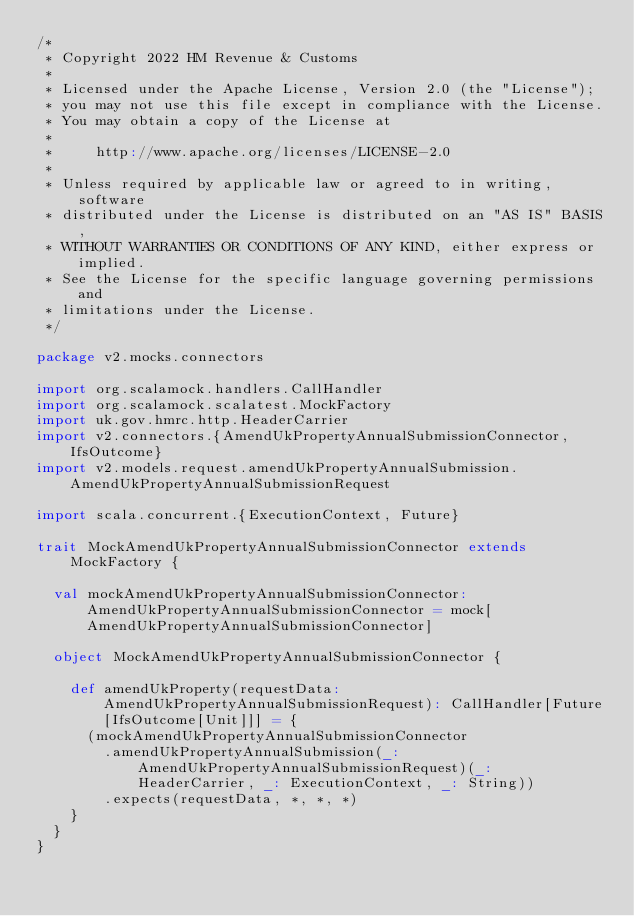Convert code to text. <code><loc_0><loc_0><loc_500><loc_500><_Scala_>/*
 * Copyright 2022 HM Revenue & Customs
 *
 * Licensed under the Apache License, Version 2.0 (the "License");
 * you may not use this file except in compliance with the License.
 * You may obtain a copy of the License at
 *
 *     http://www.apache.org/licenses/LICENSE-2.0
 *
 * Unless required by applicable law or agreed to in writing, software
 * distributed under the License is distributed on an "AS IS" BASIS,
 * WITHOUT WARRANTIES OR CONDITIONS OF ANY KIND, either express or implied.
 * See the License for the specific language governing permissions and
 * limitations under the License.
 */

package v2.mocks.connectors

import org.scalamock.handlers.CallHandler
import org.scalamock.scalatest.MockFactory
import uk.gov.hmrc.http.HeaderCarrier
import v2.connectors.{AmendUkPropertyAnnualSubmissionConnector, IfsOutcome}
import v2.models.request.amendUkPropertyAnnualSubmission.AmendUkPropertyAnnualSubmissionRequest

import scala.concurrent.{ExecutionContext, Future}

trait MockAmendUkPropertyAnnualSubmissionConnector extends MockFactory {

  val mockAmendUkPropertyAnnualSubmissionConnector: AmendUkPropertyAnnualSubmissionConnector = mock[AmendUkPropertyAnnualSubmissionConnector]

  object MockAmendUkPropertyAnnualSubmissionConnector {

    def amendUkProperty(requestData: AmendUkPropertyAnnualSubmissionRequest): CallHandler[Future[IfsOutcome[Unit]]] = {
      (mockAmendUkPropertyAnnualSubmissionConnector
        .amendUkPropertyAnnualSubmission(_: AmendUkPropertyAnnualSubmissionRequest)(_: HeaderCarrier, _: ExecutionContext, _: String))
        .expects(requestData, *, *, *)
    }
  }
}
</code> 